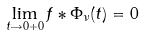<formula> <loc_0><loc_0><loc_500><loc_500>\lim _ { t \rightarrow 0 + 0 } f * \Phi _ { \nu } ( t ) = 0</formula> 